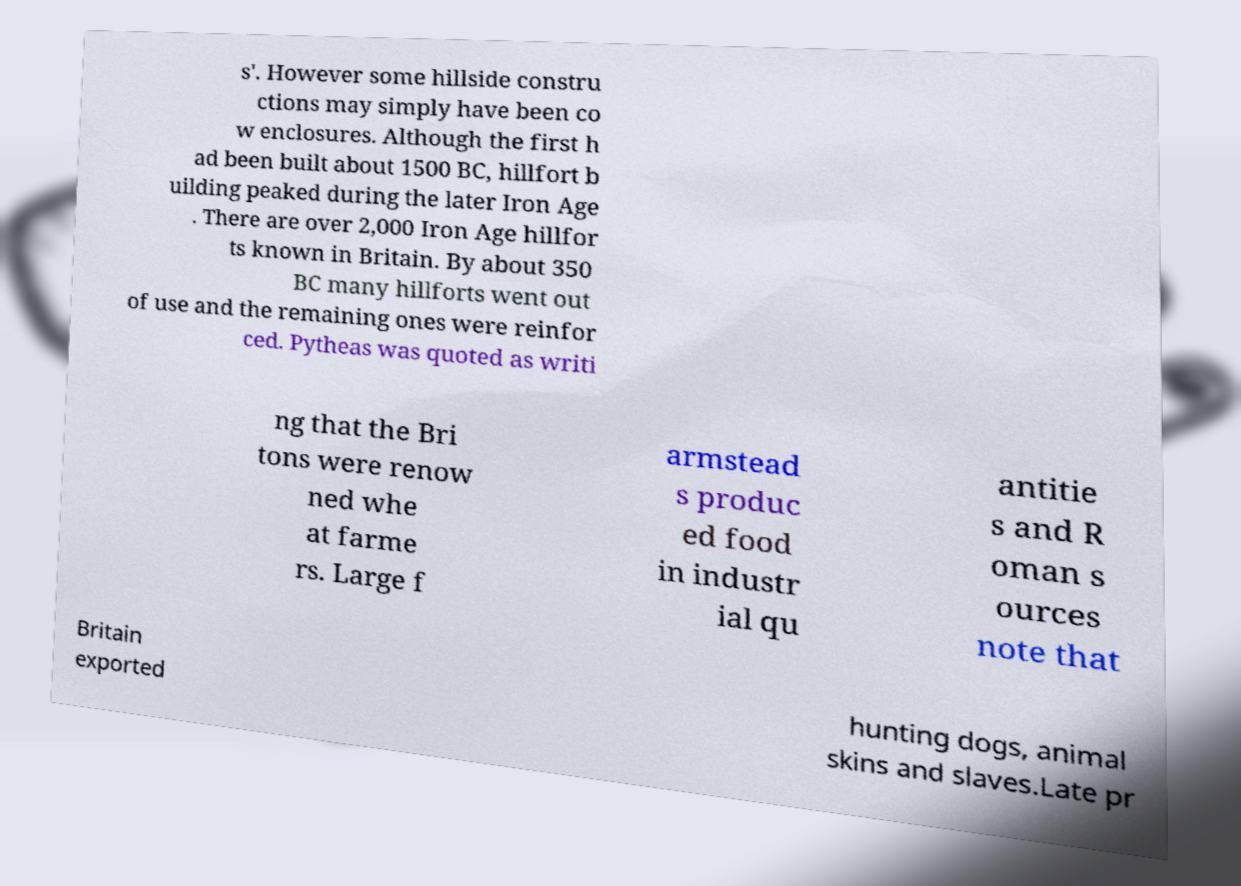I need the written content from this picture converted into text. Can you do that? s'. However some hillside constru ctions may simply have been co w enclosures. Although the first h ad been built about 1500 BC, hillfort b uilding peaked during the later Iron Age . There are over 2,000 Iron Age hillfor ts known in Britain. By about 350 BC many hillforts went out of use and the remaining ones were reinfor ced. Pytheas was quoted as writi ng that the Bri tons were renow ned whe at farme rs. Large f armstead s produc ed food in industr ial qu antitie s and R oman s ources note that Britain exported hunting dogs, animal skins and slaves.Late pr 